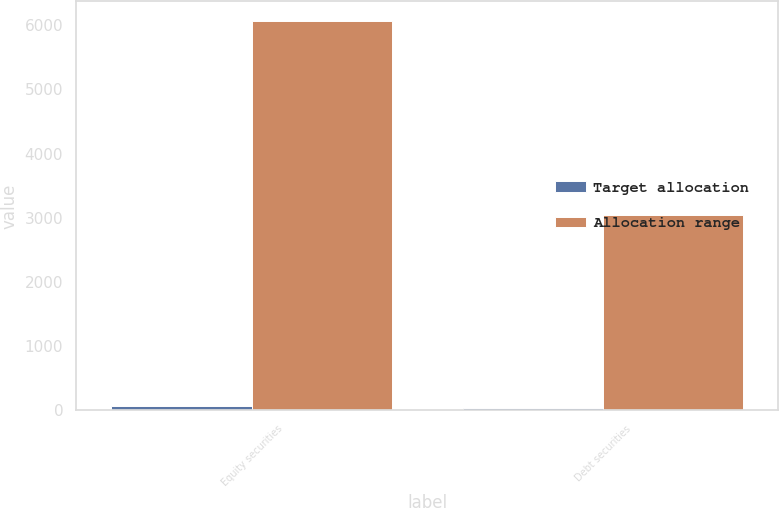<chart> <loc_0><loc_0><loc_500><loc_500><stacked_bar_chart><ecel><fcel>Equity securities<fcel>Debt securities<nl><fcel>Target allocation<fcel>65<fcel>35<nl><fcel>Allocation range<fcel>6070<fcel>3040<nl></chart> 